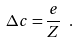<formula> <loc_0><loc_0><loc_500><loc_500>\Delta c = \frac { e } { Z } \ .</formula> 